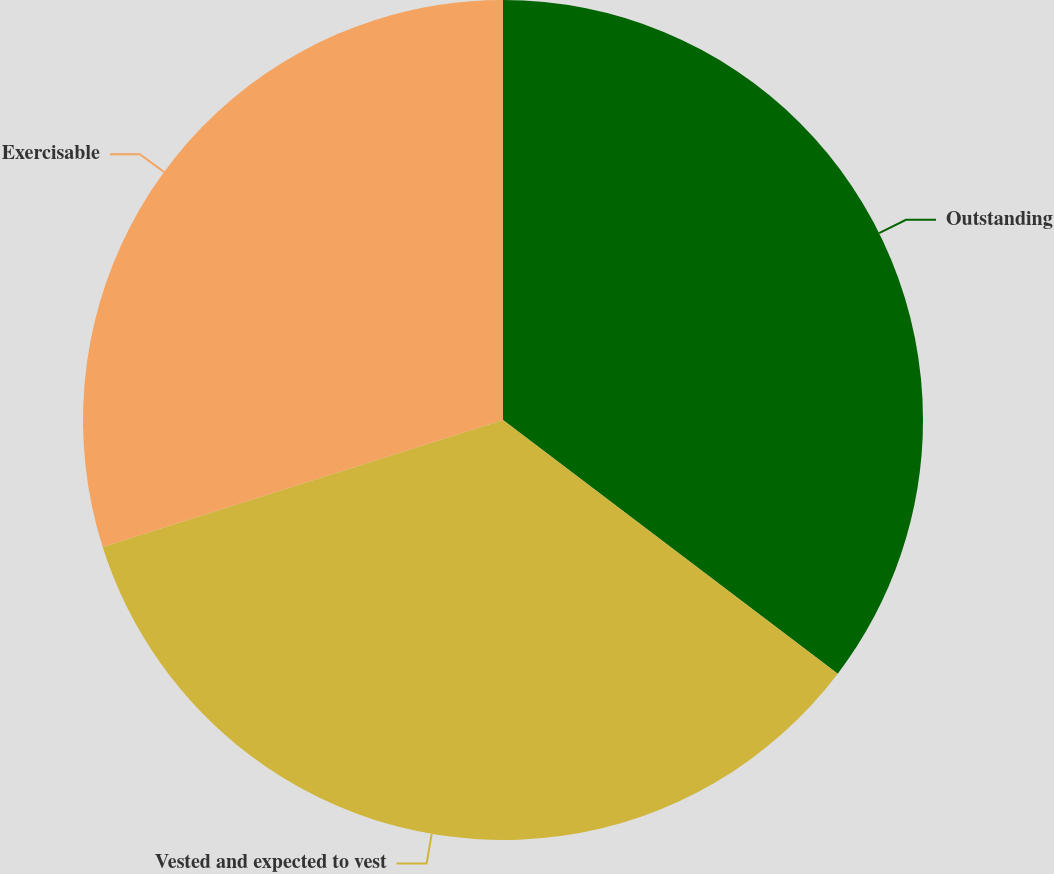Convert chart to OTSL. <chart><loc_0><loc_0><loc_500><loc_500><pie_chart><fcel>Outstanding<fcel>Vested and expected to vest<fcel>Exercisable<nl><fcel>35.32%<fcel>34.79%<fcel>29.89%<nl></chart> 